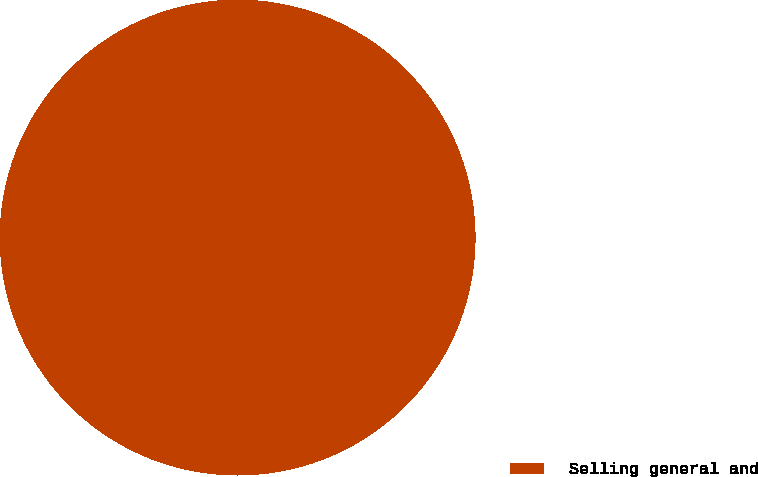Convert chart to OTSL. <chart><loc_0><loc_0><loc_500><loc_500><pie_chart><fcel>Selling general and<nl><fcel>100.0%<nl></chart> 